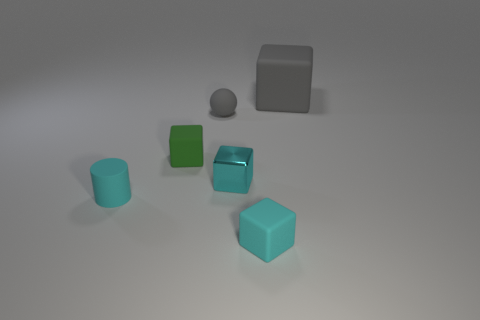Subtract all gray cylinders. How many cyan cubes are left? 2 Subtract all small green matte blocks. How many blocks are left? 3 Add 2 large purple shiny cylinders. How many objects exist? 8 Subtract 1 blocks. How many blocks are left? 3 Subtract all gray blocks. How many blocks are left? 3 Subtract all blocks. How many objects are left? 2 Subtract 0 yellow cylinders. How many objects are left? 6 Subtract all purple spheres. Subtract all brown cubes. How many spheres are left? 1 Subtract all purple rubber things. Subtract all tiny gray matte objects. How many objects are left? 5 Add 3 cyan metal objects. How many cyan metal objects are left? 4 